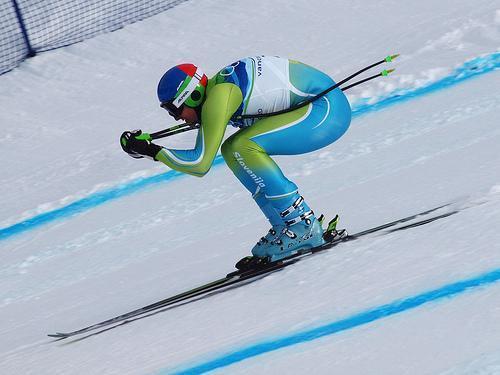How many people are in the picure?
Give a very brief answer. 1. 